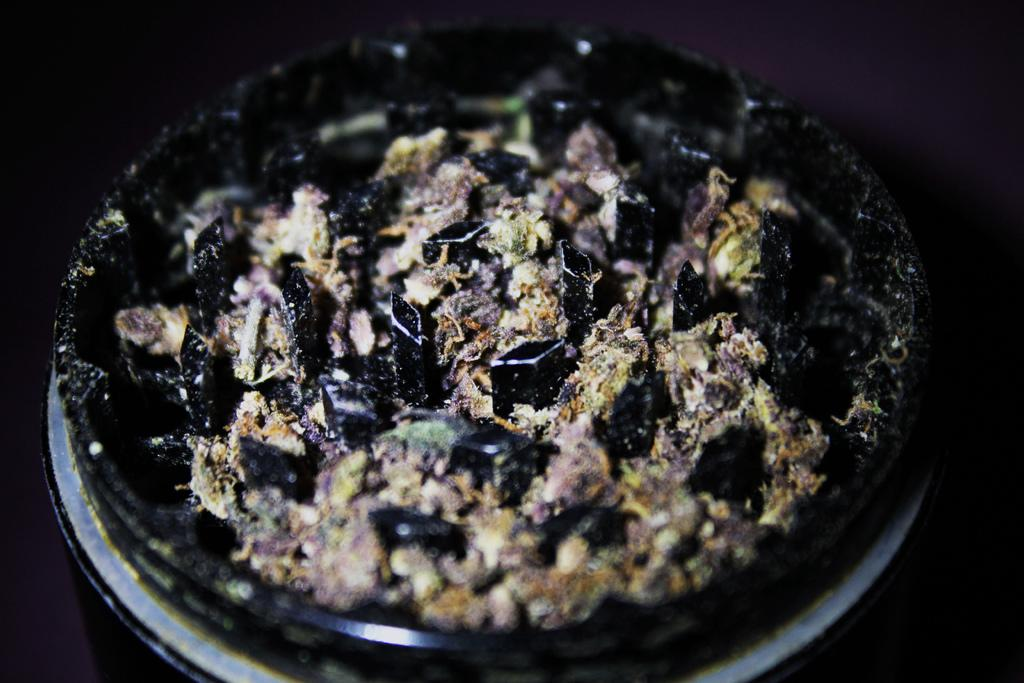What is on the plate that is visible in the image? There is a plate with food in the image. What can be observed about the lighting or color scheme of the image? The background of the image is dark. How many crackers are on the property in the image? There is no mention of crackers or a property in the image; it only features a plate with food and a dark background. 